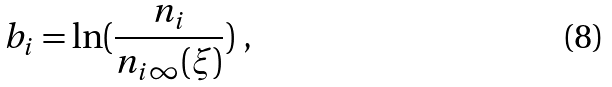<formula> <loc_0><loc_0><loc_500><loc_500>b _ { i } = \ln ( \frac { n _ { i } } { n _ { i \infty } ( \xi ) } ) \ ,</formula> 